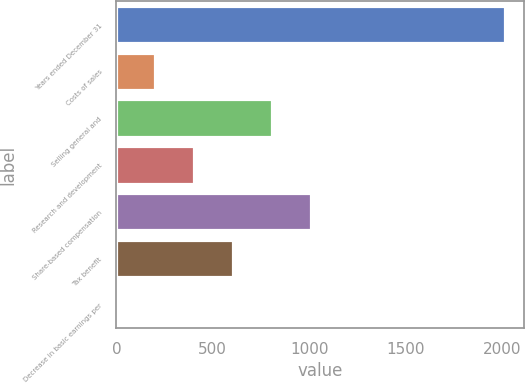Convert chart to OTSL. <chart><loc_0><loc_0><loc_500><loc_500><bar_chart><fcel>Years ended December 31<fcel>Costs of sales<fcel>Selling general and<fcel>Research and development<fcel>Share-based compensation<fcel>Tax benefit<fcel>Decrease in basic earnings per<nl><fcel>2014<fcel>201.65<fcel>805.76<fcel>403.02<fcel>1007.13<fcel>604.39<fcel>0.28<nl></chart> 